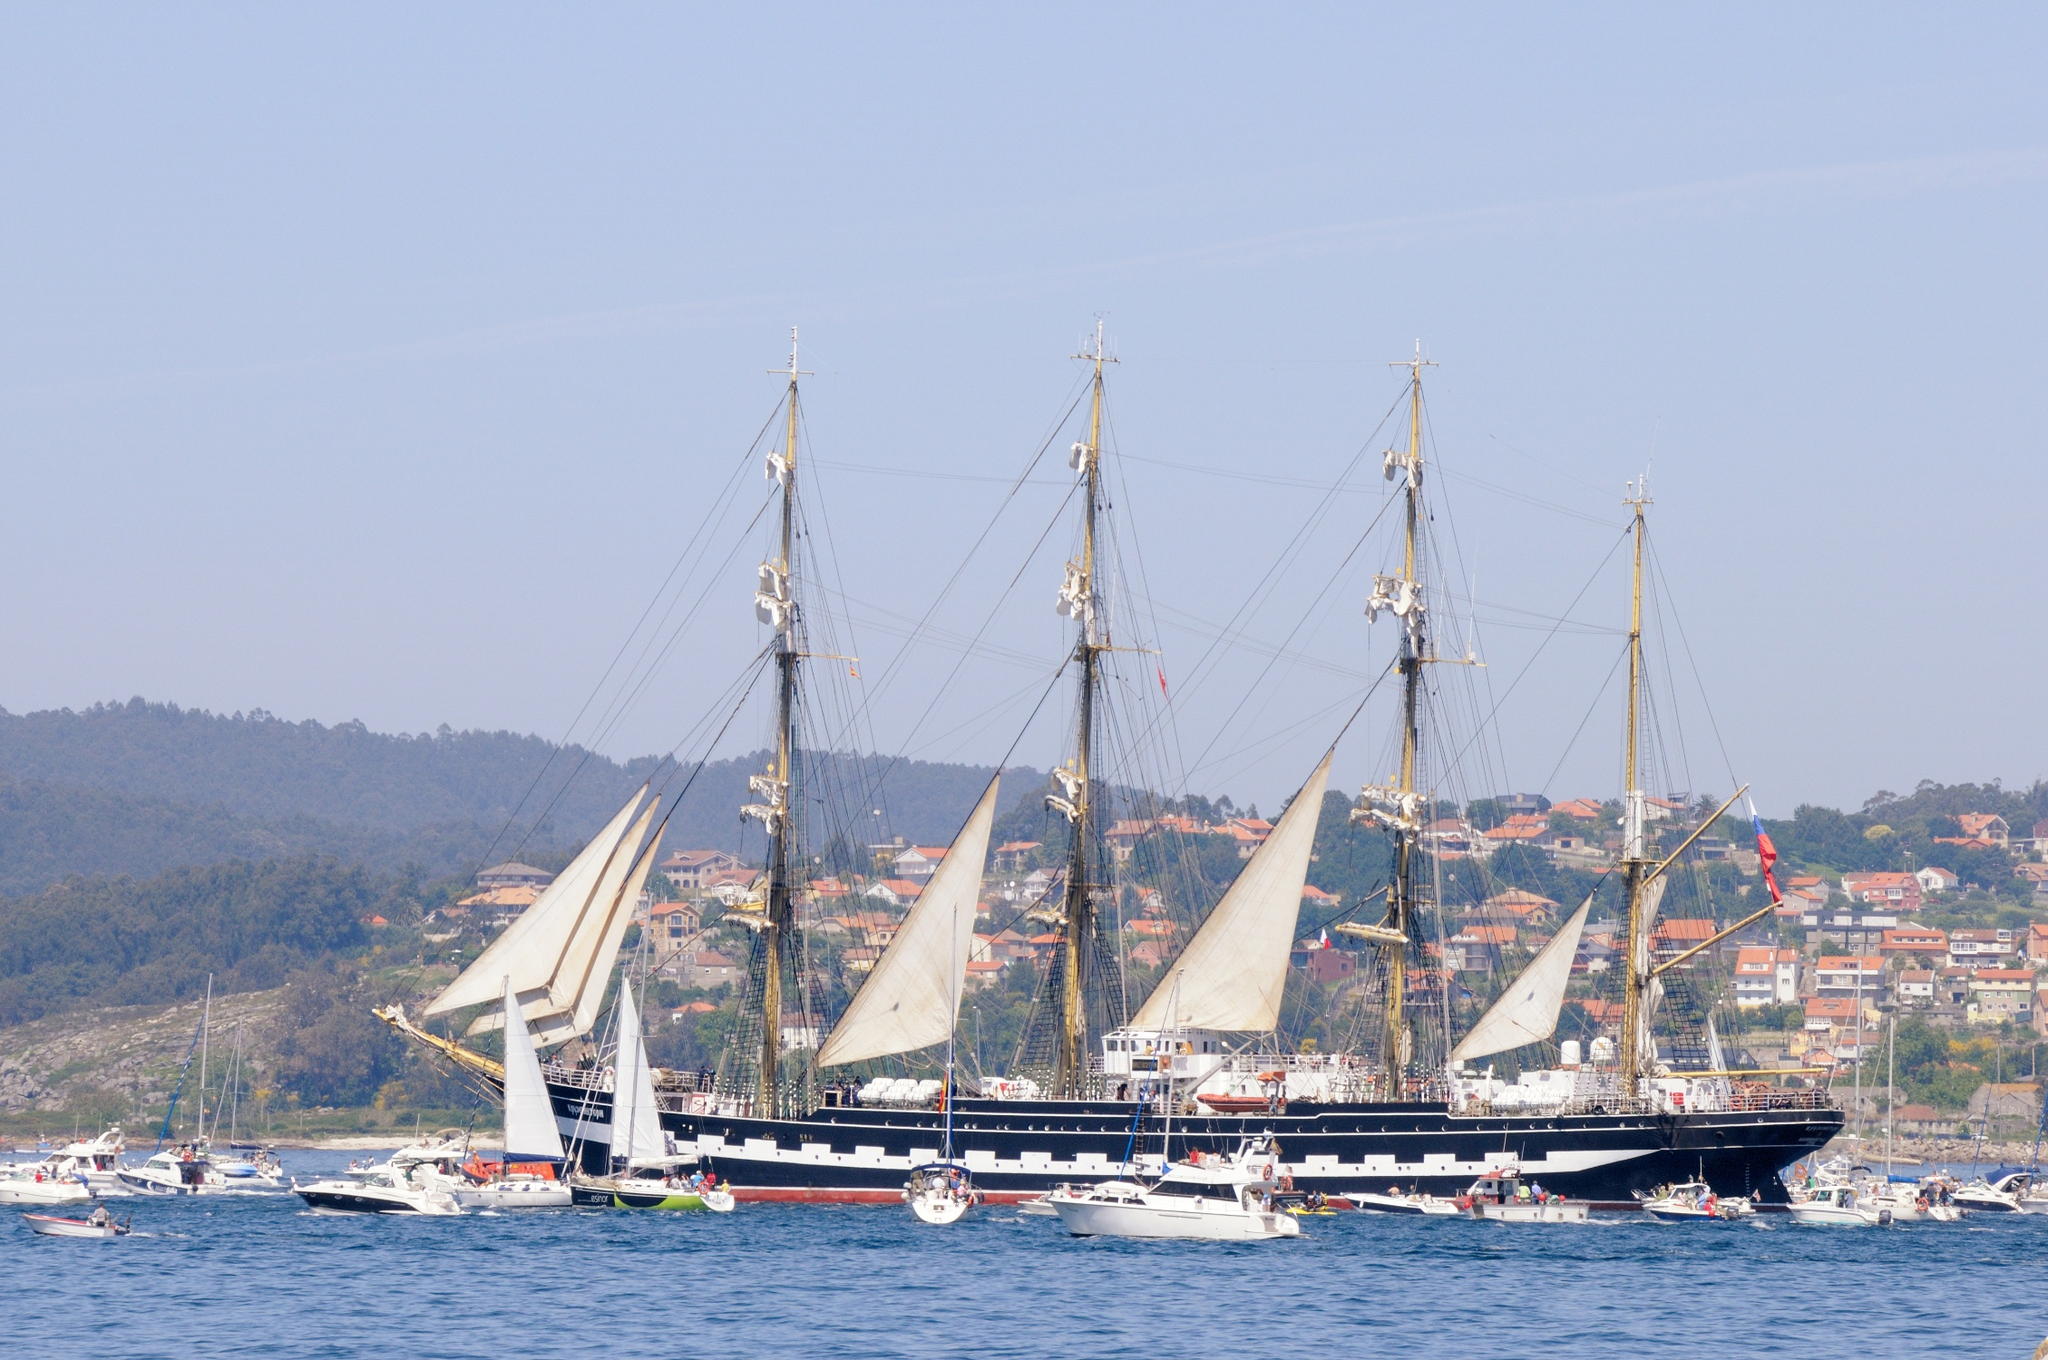Explain the visual content of the image in great detail.
 The image captures a majestic, four-masted sailing ship, painted in a striking shade of black, anchored in a serene harbor. The ship's white sails are furled, suggesting it's at rest. It's surrounded by a fleet of smaller boats, creating a lively maritime scene.

The backdrop is a picturesque hilly landscape, dotted with quaint houses and lush trees, adding a touch of tranquility to the scene. The calm water mirrors the blue sky above, enhancing the overall peaceful ambiance.

The perspective of the image is particularly interesting as it's taken from the water, looking towards the shore. This viewpoint allows for a comprehensive view of the ship in its entirety, as well as the charming coastal town in the distance. 

Unfortunately, I couldn't find specific information about the landmark "sa_10995". However, the image itself provides a captivating glimpse into a moment of maritime life. 